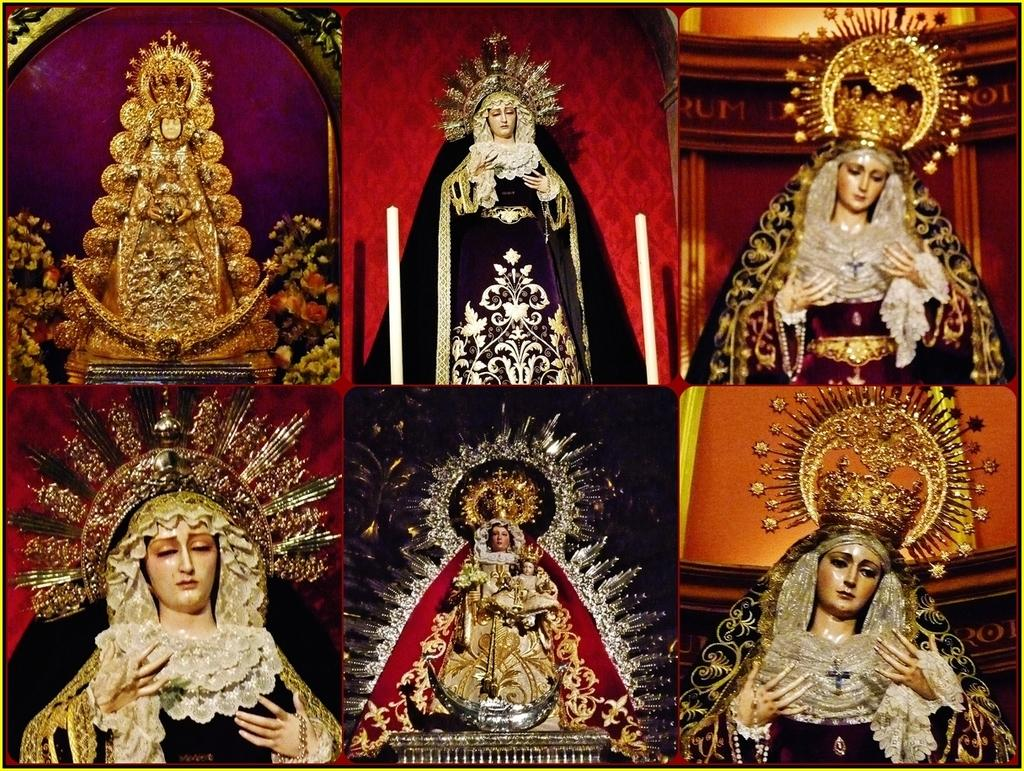What type of artwork is the image in question? The image is a collage. How many individual images are included in the collage? There are six images in the collage. Can you describe one of the images within the collage? One of the images contains statues of ladies. How many books are stacked on the wall in the image? There are no books or walls present in the image; it is a collage of six images, one of which contains statues of ladies. 